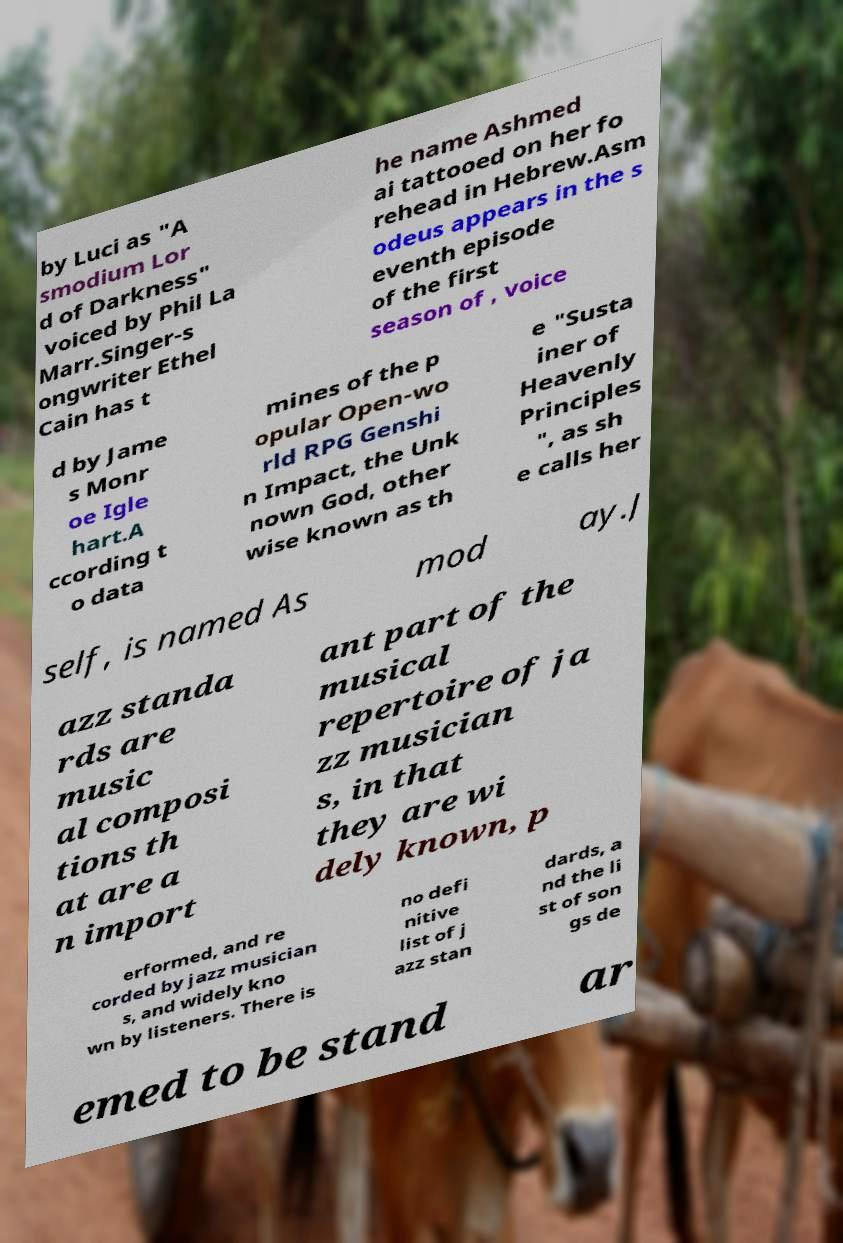There's text embedded in this image that I need extracted. Can you transcribe it verbatim? by Luci as "A smodium Lor d of Darkness" voiced by Phil La Marr.Singer-s ongwriter Ethel Cain has t he name Ashmed ai tattooed on her fo rehead in Hebrew.Asm odeus appears in the s eventh episode of the first season of , voice d by Jame s Monr oe Igle hart.A ccording t o data mines of the p opular Open-wo rld RPG Genshi n Impact, the Unk nown God, other wise known as th e "Susta iner of Heavenly Principles ", as sh e calls her self, is named As mod ay.J azz standa rds are music al composi tions th at are a n import ant part of the musical repertoire of ja zz musician s, in that they are wi dely known, p erformed, and re corded by jazz musician s, and widely kno wn by listeners. There is no defi nitive list of j azz stan dards, a nd the li st of son gs de emed to be stand ar 